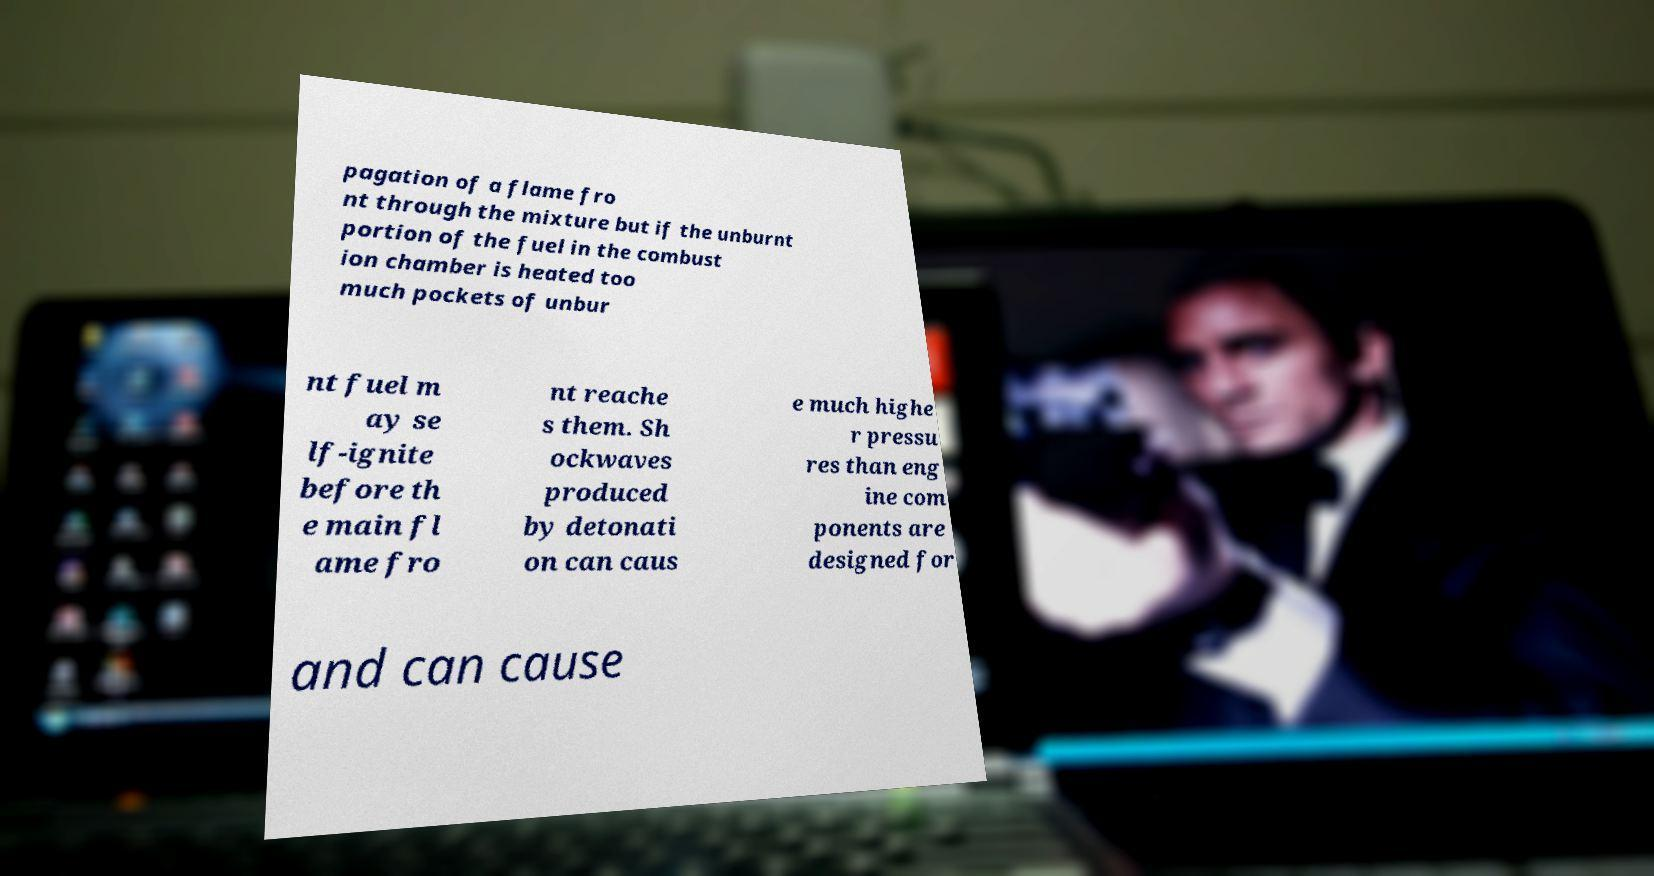Please read and relay the text visible in this image. What does it say? pagation of a flame fro nt through the mixture but if the unburnt portion of the fuel in the combust ion chamber is heated too much pockets of unbur nt fuel m ay se lf-ignite before th e main fl ame fro nt reache s them. Sh ockwaves produced by detonati on can caus e much highe r pressu res than eng ine com ponents are designed for and can cause 